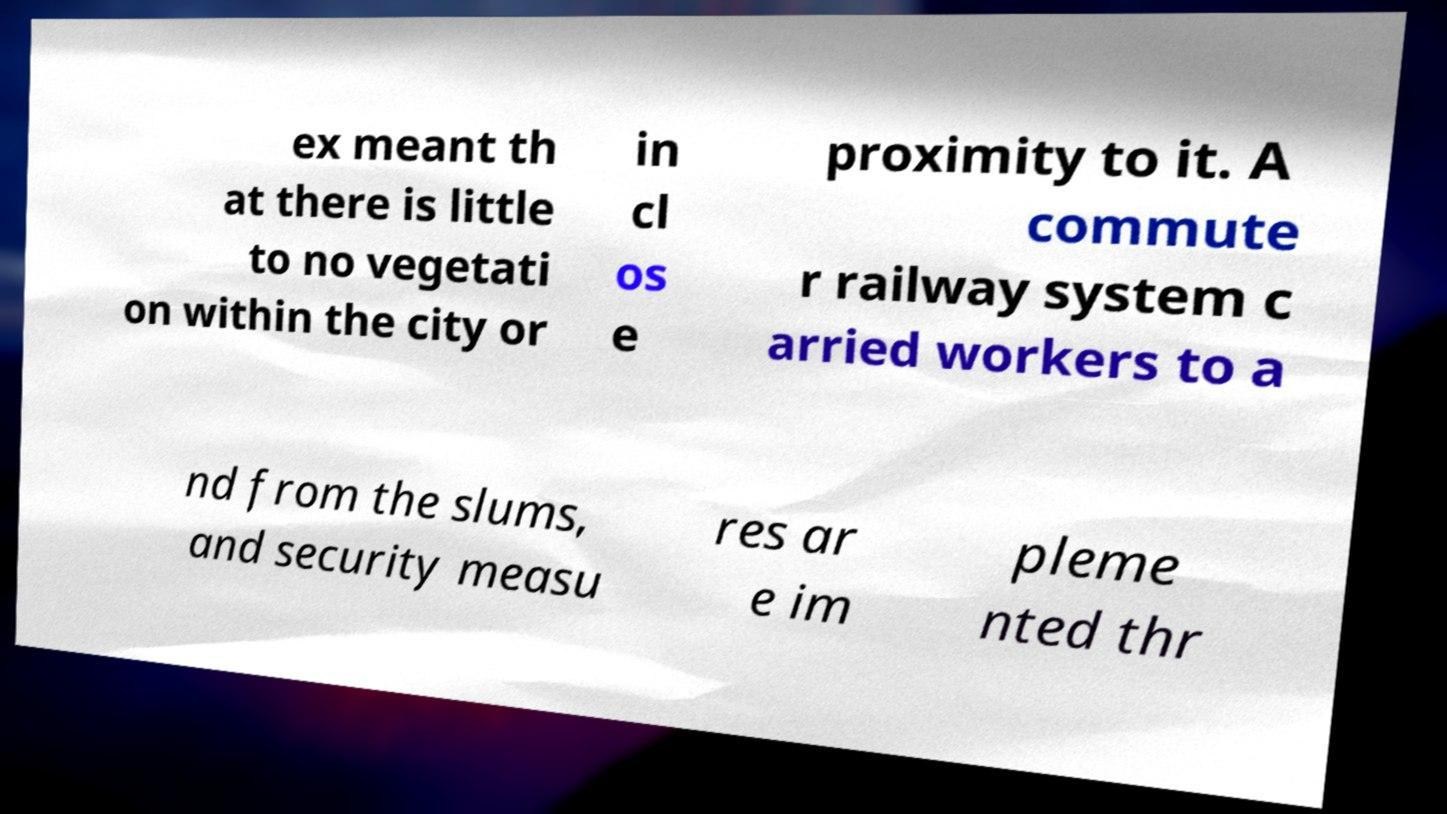I need the written content from this picture converted into text. Can you do that? ex meant th at there is little to no vegetati on within the city or in cl os e proximity to it. A commute r railway system c arried workers to a nd from the slums, and security measu res ar e im pleme nted thr 